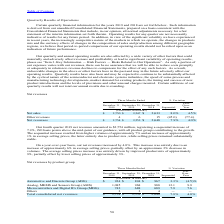According to Stmicroelectronics's financial document, What led to increase in the revenue of ADG on sequential basis? Based on the financial document, the answer is driven by an increase in volumes of approximately 8%, partially offset by a decrease in average selling prices of approximately 5%, mostly attributable to product mix.. Also, What led to increase in the revenue of AMS on sequential basis? Based on the financial document, the answer is driven by Analog and Imaging products. AMS increase was due to an increase of approximately 5% in average selling prices, entirely due to product mix, and to higher volumes of approximately of 7%.. Also, What led to increase in the revenue of MDG on sequential basis? Based on the financial document, the answer is driven by Microcontrollers, due to both higher average selling prices of approximately 6%, entirely due to product mix, and higher volumes of approximately 2%.. Also, can you calculate: What is the average net revenues from Automotive and Discrete Group (ADG) for the period December 31, 2019 and 2018? To answer this question, I need to perform calculations using the financial data. The calculation is: (924+967) / 2, which equals 945.5 (in millions). This is based on the information: "Automotive and Discrete Group (ADG) $ 924 $ 894 $ 967 3.3% (4.5)% Automotive and Discrete Group (ADG) $ 924 $ 894 $ 967 3.3% (4.5)%..." The key data points involved are: 924, 967. Also, can you calculate: What is the average net revenues from Analog, MEMS and Sensors Group (AMS) for the period December 31, 2019 and 2018? To answer this question, I need to perform calculations using the financial data. The calculation is: (1,085+988) / 2, which equals 1036.5 (in millions). This is based on the information: "Analog, MEMS and Sensors Group (AMS) 1,085 968 988 12.1 9.9 Analog, MEMS and Sensors Group (AMS) 1,085 968 988 12.1 9.9..." The key data points involved are: 1,085, 988. Also, can you calculate: What is the average net revenues from Microcontrollers and Digital ICs Group (MDG) for the period December 31, 2019 and 2018? To answer this question, I need to perform calculations using the financial data. The calculation is: (742+689) / 2 , which equals 715.5 (in millions). This is based on the information: "rocontrollers and Digital ICs Group (MDG) 742 688 689 7.9 7.6 Microcontrollers and Digital ICs Group (MDG) 742 688 689 7.9 7.6..." The key data points involved are: 689, 742. 